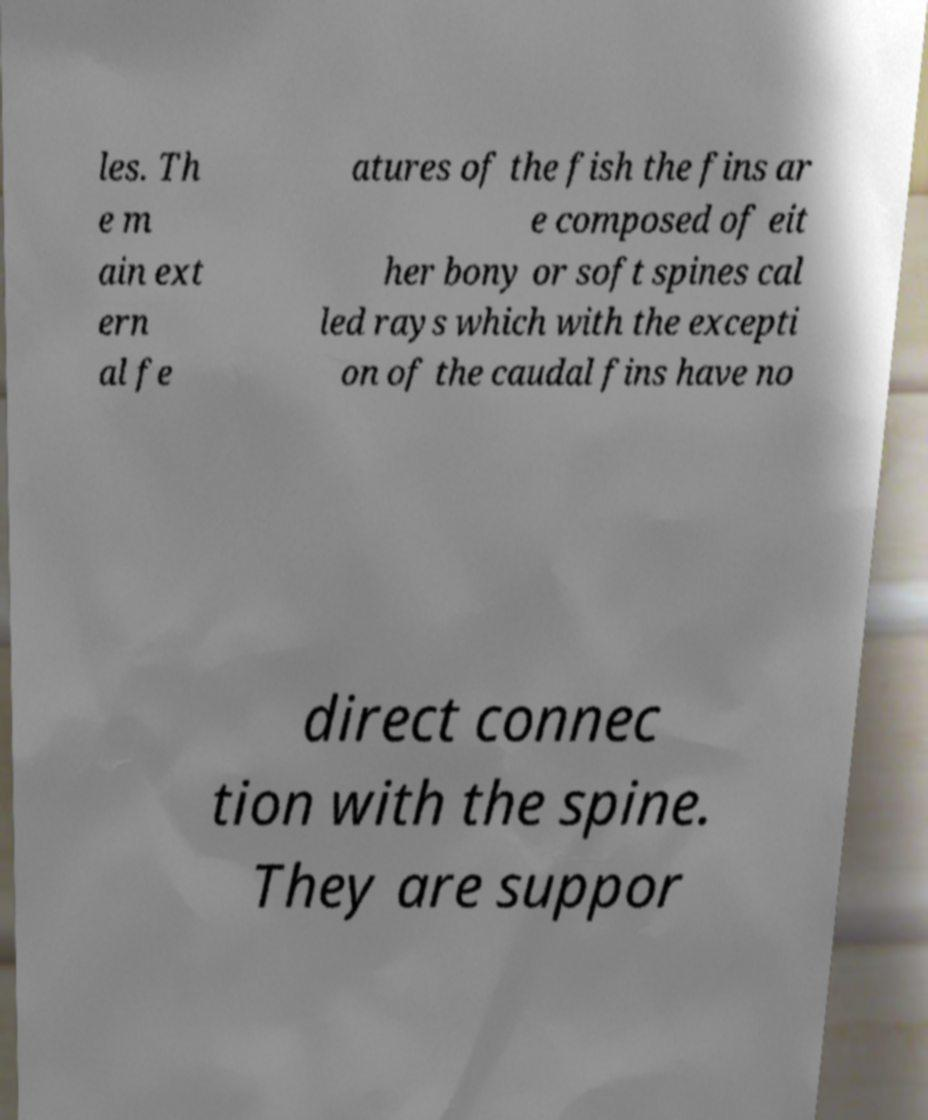I need the written content from this picture converted into text. Can you do that? les. Th e m ain ext ern al fe atures of the fish the fins ar e composed of eit her bony or soft spines cal led rays which with the excepti on of the caudal fins have no direct connec tion with the spine. They are suppor 